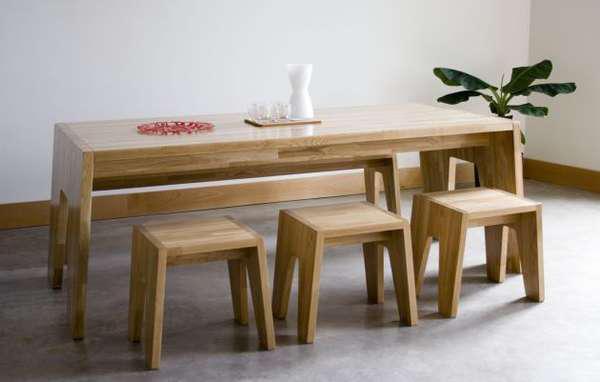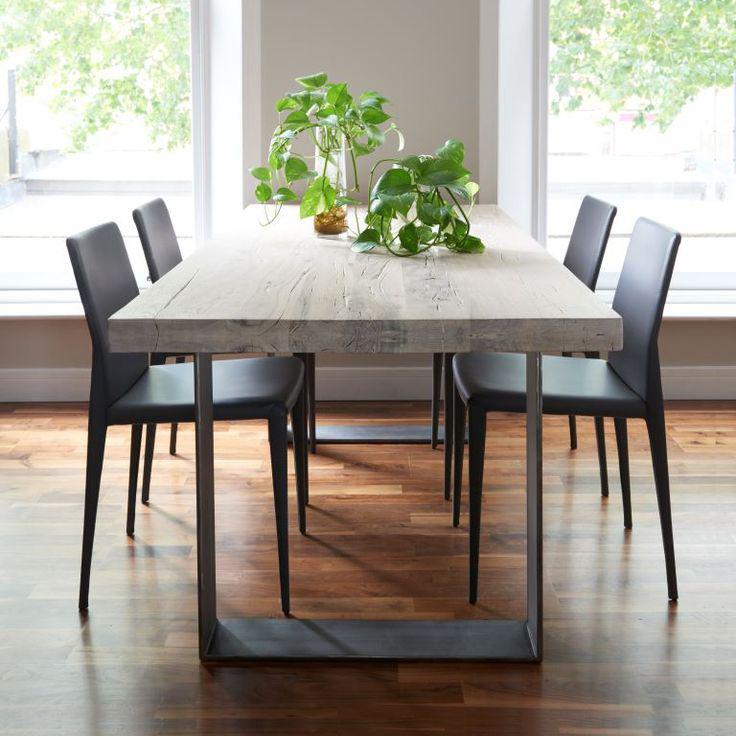The first image is the image on the left, the second image is the image on the right. For the images displayed, is the sentence "There is a vase on the table in the image on the right." factually correct? Answer yes or no. Yes. The first image is the image on the left, the second image is the image on the right. Examine the images to the left and right. Is the description "In one image, a rectangular table has long bench seating on one side." accurate? Answer yes or no. Yes. 